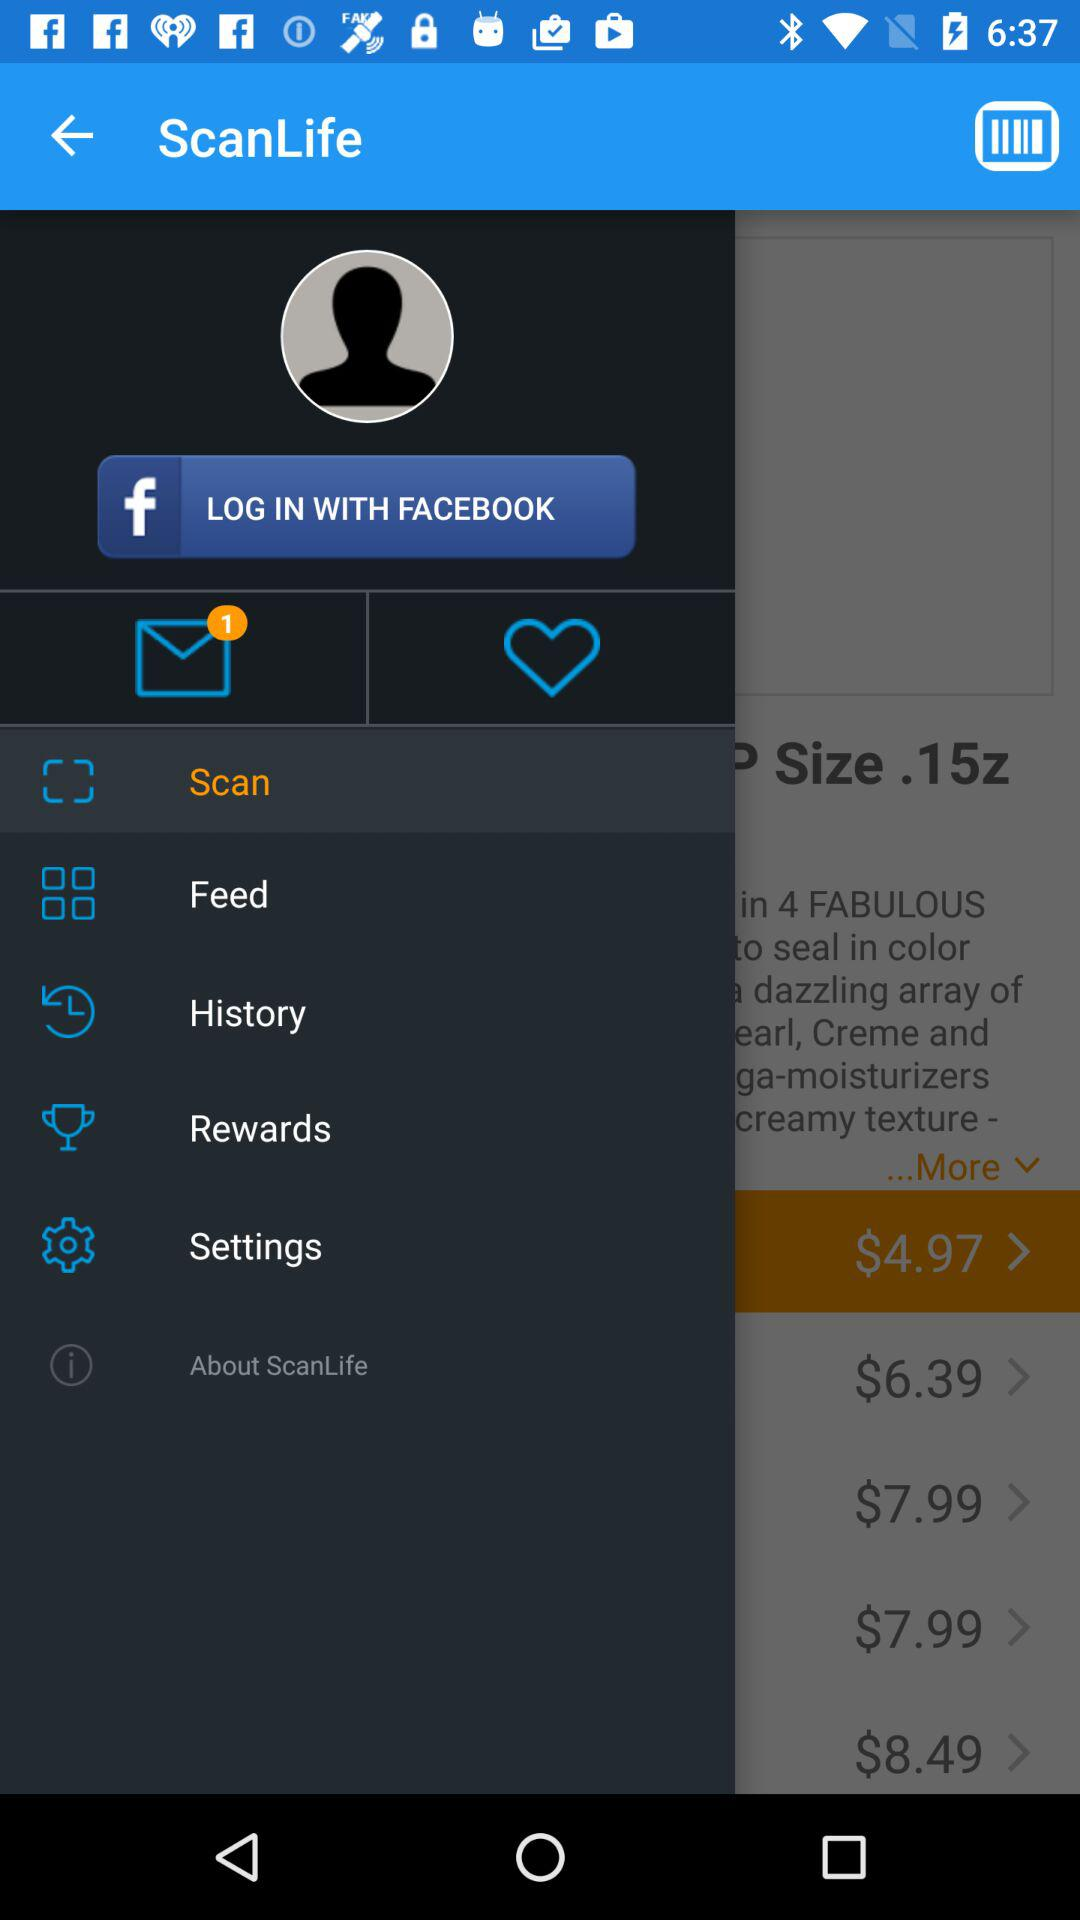How many unread messages are there? There is 1 unread message. 